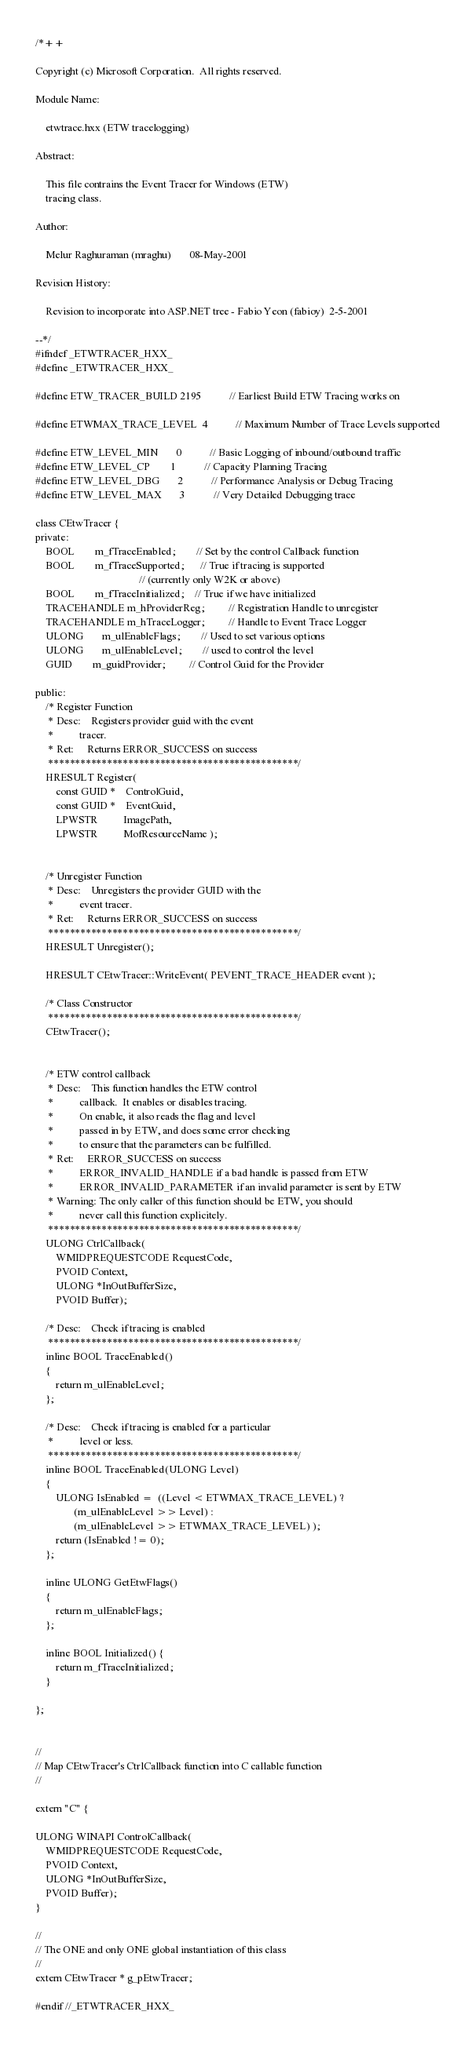<code> <loc_0><loc_0><loc_500><loc_500><_C_>/*++

Copyright (c) Microsoft Corporation.  All rights reserved.

Module Name:

    etwtrace.hxx (ETW tracelogging)

Abstract:

    This file contrains the Event Tracer for Windows (ETW)
    tracing class. 

Author:

    Melur Raghuraman (mraghu)       08-May-2001

Revision History:

    Revision to incorporate into ASP.NET tree - Fabio Yeon (fabioy)  2-5-2001

--*/
#ifndef _ETWTRACER_HXX_
#define _ETWTRACER_HXX_

#define ETW_TRACER_BUILD 2195           // Earliest Build ETW Tracing works on

#define ETWMAX_TRACE_LEVEL  4           // Maximum Number of Trace Levels supported

#define ETW_LEVEL_MIN       0           // Basic Logging of inbound/outbound traffic
#define ETW_LEVEL_CP        1           // Capacity Planning Tracing 
#define ETW_LEVEL_DBG       2           // Performance Analysis or Debug Tracing
#define ETW_LEVEL_MAX       3           // Very Detailed Debugging trace

class CEtwTracer {
private:
    BOOL        m_fTraceEnabled;        // Set by the control Callback function
    BOOL        m_fTraceSupported;      // True if tracing is supported 
                                        // (currently only W2K or above)
    BOOL        m_fTraceInitialized;    // True if we have initialized 
    TRACEHANDLE m_hProviderReg;         // Registration Handle to unregister
    TRACEHANDLE m_hTraceLogger;         // Handle to Event Trace Logger
    ULONG       m_ulEnableFlags;        // Used to set various options
    ULONG       m_ulEnableLevel;        // used to control the level
    GUID        m_guidProvider;         // Control Guid for the Provider

public:
    /* Register Function
     * Desc:    Registers provider guid with the event
     *          tracer.  
     * Ret:     Returns ERROR_SUCCESS on success
     ***********************************************/
    HRESULT Register(
        const GUID *    ControlGuid,
        const GUID *    EventGuid,
        LPWSTR          ImagePath,
        LPWSTR          MofResourceName );


    /* Unregister Function
     * Desc:    Unregisters the provider GUID with the
     *          event tracer.
     * Ret:     Returns ERROR_SUCCESS on success
     ***********************************************/
    HRESULT Unregister();

    HRESULT CEtwTracer::WriteEvent( PEVENT_TRACE_HEADER event );

    /* Class Constructor
     ***********************************************/
    CEtwTracer();


    /* ETW control callback
     * Desc:    This function handles the ETW control
     *          callback.  It enables or disables tracing.
     *          On enable, it also reads the flag and level
     *          passed in by ETW, and does some error checking
     *          to ensure that the parameters can be fulfilled.
     * Ret:     ERROR_SUCCESS on success
     *          ERROR_INVALID_HANDLE if a bad handle is passed from ETW
     *          ERROR_INVALID_PARAMETER if an invalid parameter is sent by ETW
     * Warning: The only caller of this function should be ETW, you should
     *          never call this function explicitely.
     ***********************************************/
    ULONG CtrlCallback(
        WMIDPREQUESTCODE RequestCode,
        PVOID Context,
        ULONG *InOutBufferSize, 
        PVOID Buffer);

    /* Desc:    Check if tracing is enabled
     ***********************************************/
    inline BOOL TraceEnabled()
    { 
        return m_ulEnableLevel;
    };

    /* Desc:    Check if tracing is enabled for a particular
     *          level or less.
     ***********************************************/
    inline BOOL TraceEnabled(ULONG Level) 
    { 
        ULONG IsEnabled =  ((Level < ETWMAX_TRACE_LEVEL) ? 
               (m_ulEnableLevel >> Level) : 
               (m_ulEnableLevel >> ETWMAX_TRACE_LEVEL) );  
        return (IsEnabled != 0);
    };

    inline ULONG GetEtwFlags()
    { 
        return m_ulEnableFlags;
    };

    inline BOOL Initialized() {
        return m_fTraceInitialized;
    }
    
};


//
// Map CEtwTracer's CtrlCallback function into C callable function
//

extern "C" {

ULONG WINAPI ControlCallback(
    WMIDPREQUESTCODE RequestCode,
    PVOID Context,
    ULONG *InOutBufferSize, 
    PVOID Buffer);
}

//
// The ONE and only ONE global instantiation of this class
//
extern CEtwTracer * g_pEtwTracer;

#endif //_ETWTRACER_HXX_

</code> 